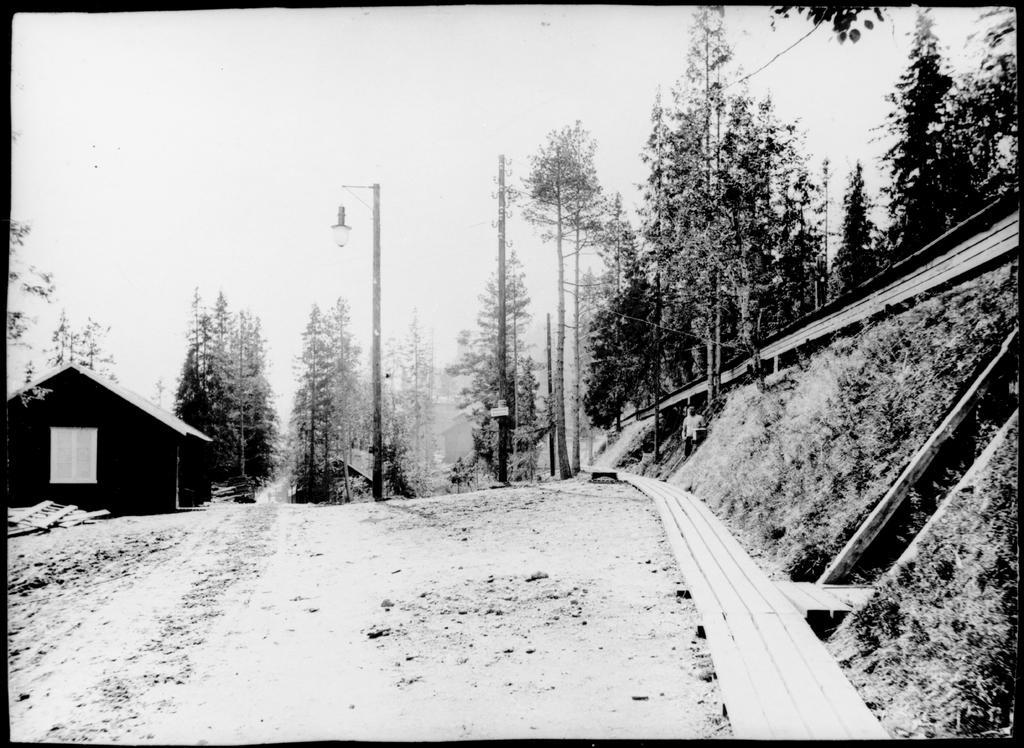Could you give a brief overview of what you see in this image? In this image in the middle there are trees, house, man, grassland, streetlight, poles, sky. 